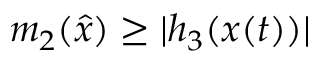<formula> <loc_0><loc_0><loc_500><loc_500>m _ { 2 } ( { \hat { x } } ) \geq | h _ { 3 } ( x ( t ) ) |</formula> 